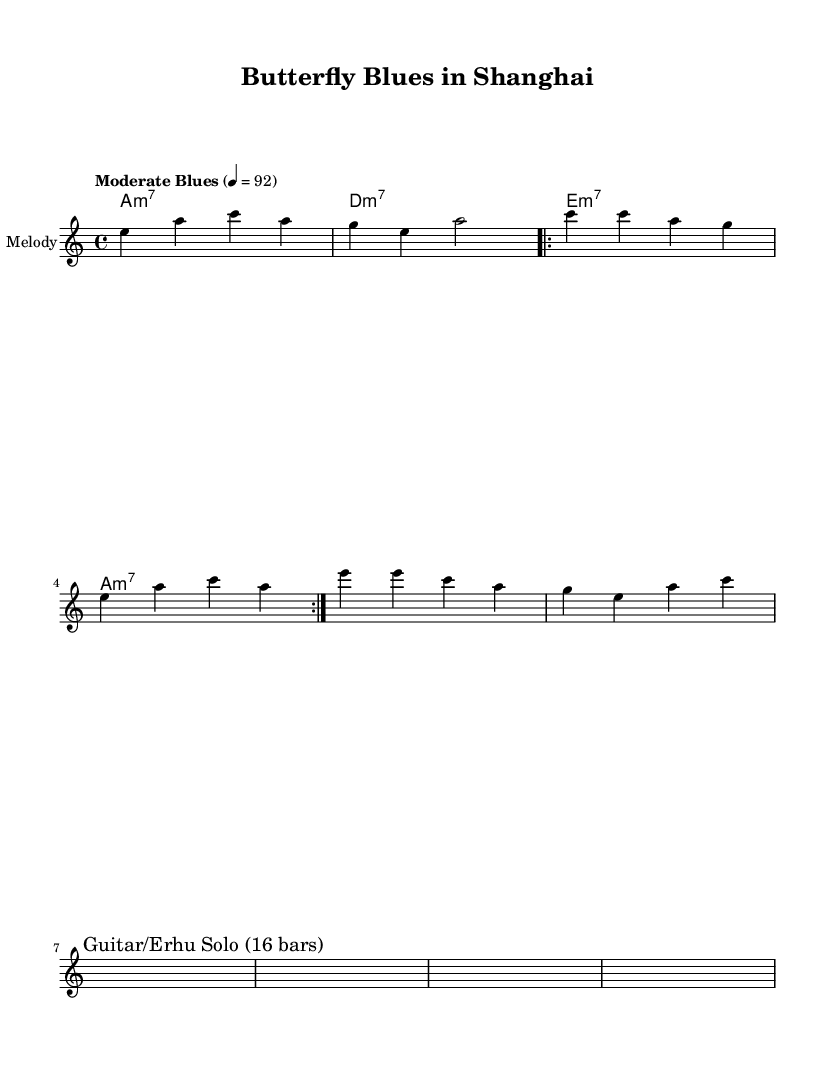What is the key signature of this music? The key signature marked in the sheet music is A minor, which typically consists of no sharps or flats. It can be identified from the "global" block where the key is stated as \key a \minor.
Answer: A minor What is the time signature of this music? The time signature indicated in the music is 4/4, meaning there are four beats in each measure and the quarter note gets one beat. This is seen under the "global" block with the notation \time 4/4.
Answer: 4/4 What is the tempo indication provided for this piece? The tempo is indicated as "Moderate Blues," with a metronome marking of quarter note = 92. This is clear from the "global" section where it states \tempo "Moderate Blues" 4 = 92.
Answer: Moderate Blues, 92 How many bars are indicated for the solo section? The solo section is hinted to contain 16 bars as explicitly stated in the music under the "Solo section hint." This interpretation comes from the text saying "Guitar/Erhu Solo (16 bars)."
Answer: 16 What kind of instruments are suggested for the solo section? The instruments suggested for the solo are Guitar and Erhu, which is a traditional East Asian instrument. This is directly referred to in the sheet music under the section that mentions "Guitar/Erhu Solo."
Answer: Guitar, Erhu How many times is the verse repeated? The verse is indicated to be repeated 2 times as noted in the melody section where it contains the command \repeat volta 2 before the verse's musical lines. This notation explicitly marks the repeat behavior.
Answer: 2 What thematic elements can be found in the lyrics? The thematic elements in the lyrics revolve around butterflies and beauty, as seen with phrases like "Wings of silk" and "Moth to a flame." These lyrics encompass the imagery of butterflies relating to the overall theme.
Answer: Butterflies, beauty 